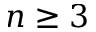<formula> <loc_0><loc_0><loc_500><loc_500>n \geq 3</formula> 